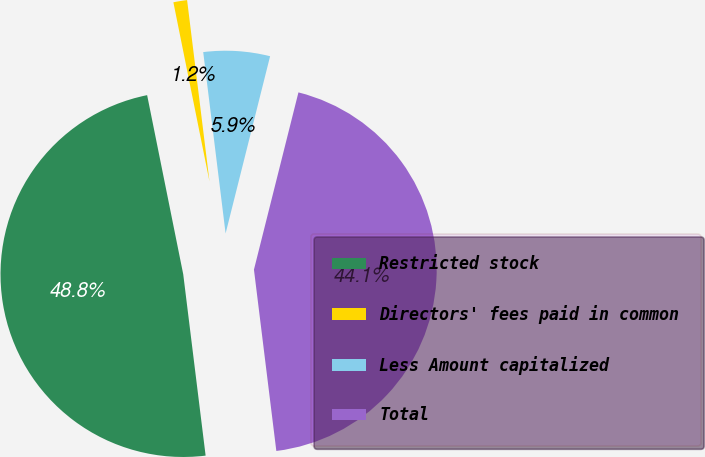<chart> <loc_0><loc_0><loc_500><loc_500><pie_chart><fcel>Restricted stock<fcel>Directors' fees paid in common<fcel>Less Amount capitalized<fcel>Total<nl><fcel>48.79%<fcel>1.21%<fcel>5.87%<fcel>44.13%<nl></chart> 